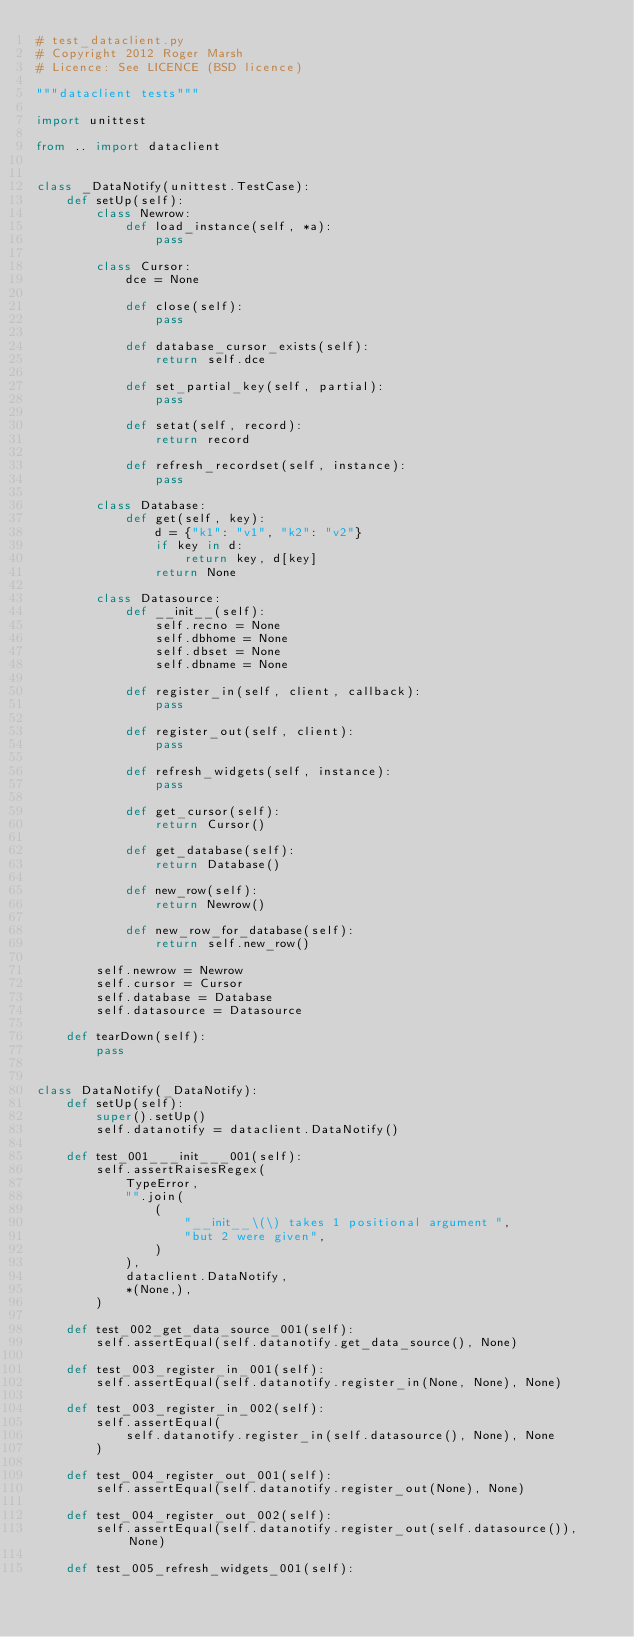Convert code to text. <code><loc_0><loc_0><loc_500><loc_500><_Python_># test_dataclient.py
# Copyright 2012 Roger Marsh
# Licence: See LICENCE (BSD licence)

"""dataclient tests"""

import unittest

from .. import dataclient


class _DataNotify(unittest.TestCase):
    def setUp(self):
        class Newrow:
            def load_instance(self, *a):
                pass

        class Cursor:
            dce = None

            def close(self):
                pass

            def database_cursor_exists(self):
                return self.dce

            def set_partial_key(self, partial):
                pass

            def setat(self, record):
                return record

            def refresh_recordset(self, instance):
                pass

        class Database:
            def get(self, key):
                d = {"k1": "v1", "k2": "v2"}
                if key in d:
                    return key, d[key]
                return None

        class Datasource:
            def __init__(self):
                self.recno = None
                self.dbhome = None
                self.dbset = None
                self.dbname = None

            def register_in(self, client, callback):
                pass

            def register_out(self, client):
                pass

            def refresh_widgets(self, instance):
                pass

            def get_cursor(self):
                return Cursor()

            def get_database(self):
                return Database()

            def new_row(self):
                return Newrow()

            def new_row_for_database(self):
                return self.new_row()

        self.newrow = Newrow
        self.cursor = Cursor
        self.database = Database
        self.datasource = Datasource

    def tearDown(self):
        pass


class DataNotify(_DataNotify):
    def setUp(self):
        super().setUp()
        self.datanotify = dataclient.DataNotify()

    def test_001___init___001(self):
        self.assertRaisesRegex(
            TypeError,
            "".join(
                (
                    "__init__\(\) takes 1 positional argument ",
                    "but 2 were given",
                )
            ),
            dataclient.DataNotify,
            *(None,),
        )

    def test_002_get_data_source_001(self):
        self.assertEqual(self.datanotify.get_data_source(), None)

    def test_003_register_in_001(self):
        self.assertEqual(self.datanotify.register_in(None, None), None)

    def test_003_register_in_002(self):
        self.assertEqual(
            self.datanotify.register_in(self.datasource(), None), None
        )

    def test_004_register_out_001(self):
        self.assertEqual(self.datanotify.register_out(None), None)

    def test_004_register_out_002(self):
        self.assertEqual(self.datanotify.register_out(self.datasource()), None)

    def test_005_refresh_widgets_001(self):</code> 